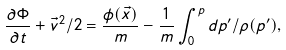<formula> <loc_0><loc_0><loc_500><loc_500>\frac { \partial \Phi } { \partial t } + \vec { v } ^ { 2 } / 2 = \frac { \phi ( \vec { x } ) } { m } - \frac { 1 } { m } \int ^ { p } _ { 0 } d p ^ { \prime } / \rho ( p ^ { \prime } ) ,</formula> 